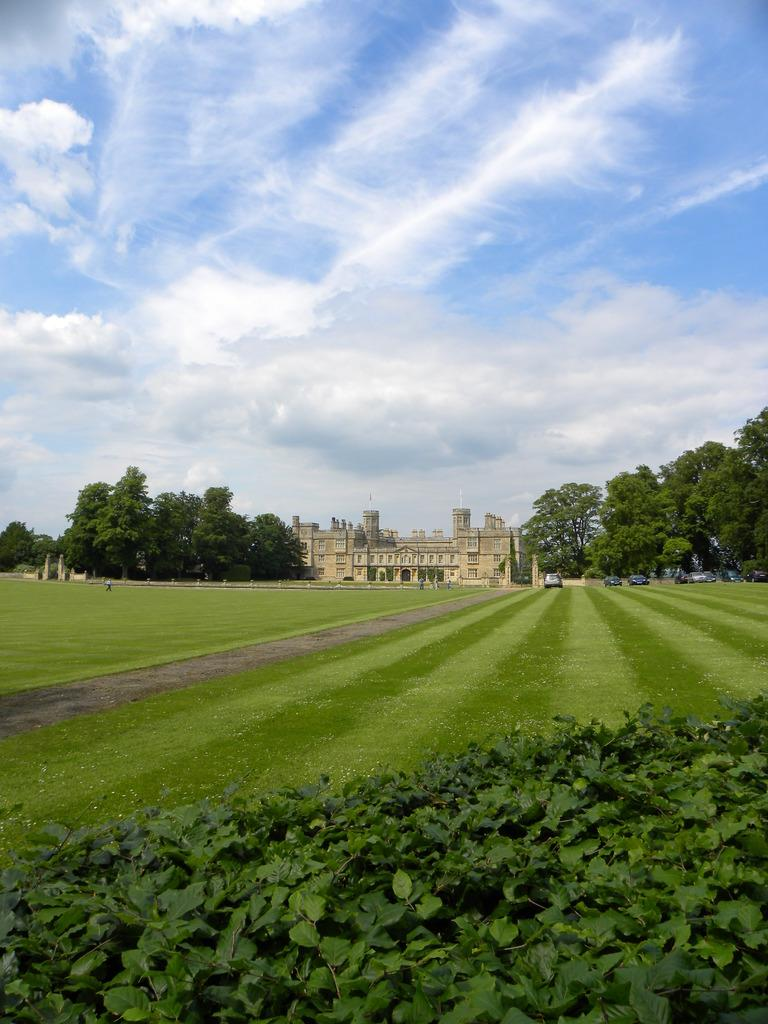What type of structure can be seen in the image? There is a building in the image. What can be found near the building? There is a path in the image. What type of vegetation is present in the image? Grass and trees are present in the image. How would you describe the weather in the image? The sky is cloudy in the image. Are there any vehicles visible in the image? Yes, there are vehicles visible in the image. Can you see any goats performing magic tricks in the image? There are no goats or magic tricks present in the image. Is there a bomb visible in the image? There is no bomb present in the image. 